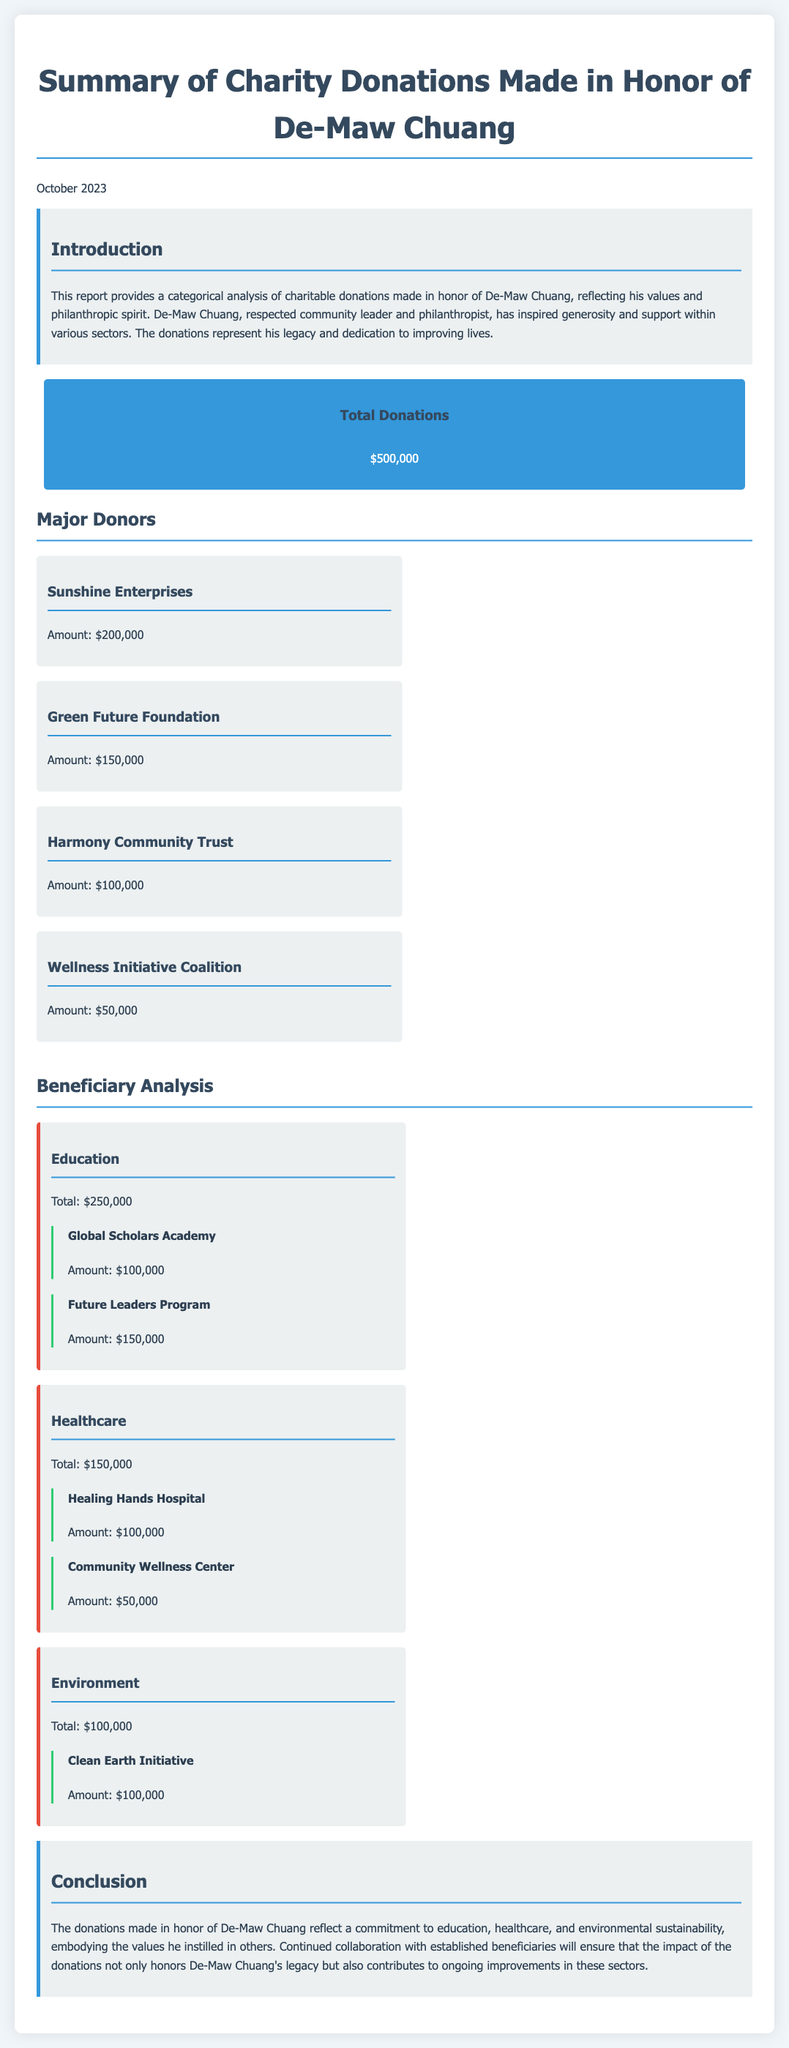What is the total amount of donations? The total donations reported in the document is specified in the summary section, which states the total donations as $500,000.
Answer: $500,000 Who is the major donor contributing the most? The document lists major donors and their contributions; the one with the highest amount is Sunshine Enterprises contributing $200,000.
Answer: Sunshine Enterprises How much was donated to the Healthcare category? The document provides a breakdown of donations by category, with Healthcare receiving a total of $150,000.
Answer: $150,000 Which organization received the highest donation within the Education category? The beneficiaries within the Education category are listed with amounts, and Global Scholars Academy received the highest amount of $100,000.
Answer: Global Scholars Academy What is the total amount allocated to Environmental causes? The document states that the total donations for the Environment category is specified as $100,000.
Answer: $100,000 How many beneficiaries are listed under the Healthcare category? The document specifies two beneficiaries listed under the Healthcare category: Healing Hands Hospital and Community Wellness Center.
Answer: Two What percentage of the total donations went to Education? The Education category received $250,000 out of the total $500,000, which is 50 percent of the total donations.
Answer: 50 percent What is the purpose of the report? The introduction describes the report's purpose as providing a categorical analysis of charitable donations made in honor of De-Maw Chuang.
Answer: Categorical analysis Who is honored by these donations? The introduction states that the donations are made in honor of De-Maw Chuang, reflecting his legacy and philanthropic spirit.
Answer: De-Maw Chuang 